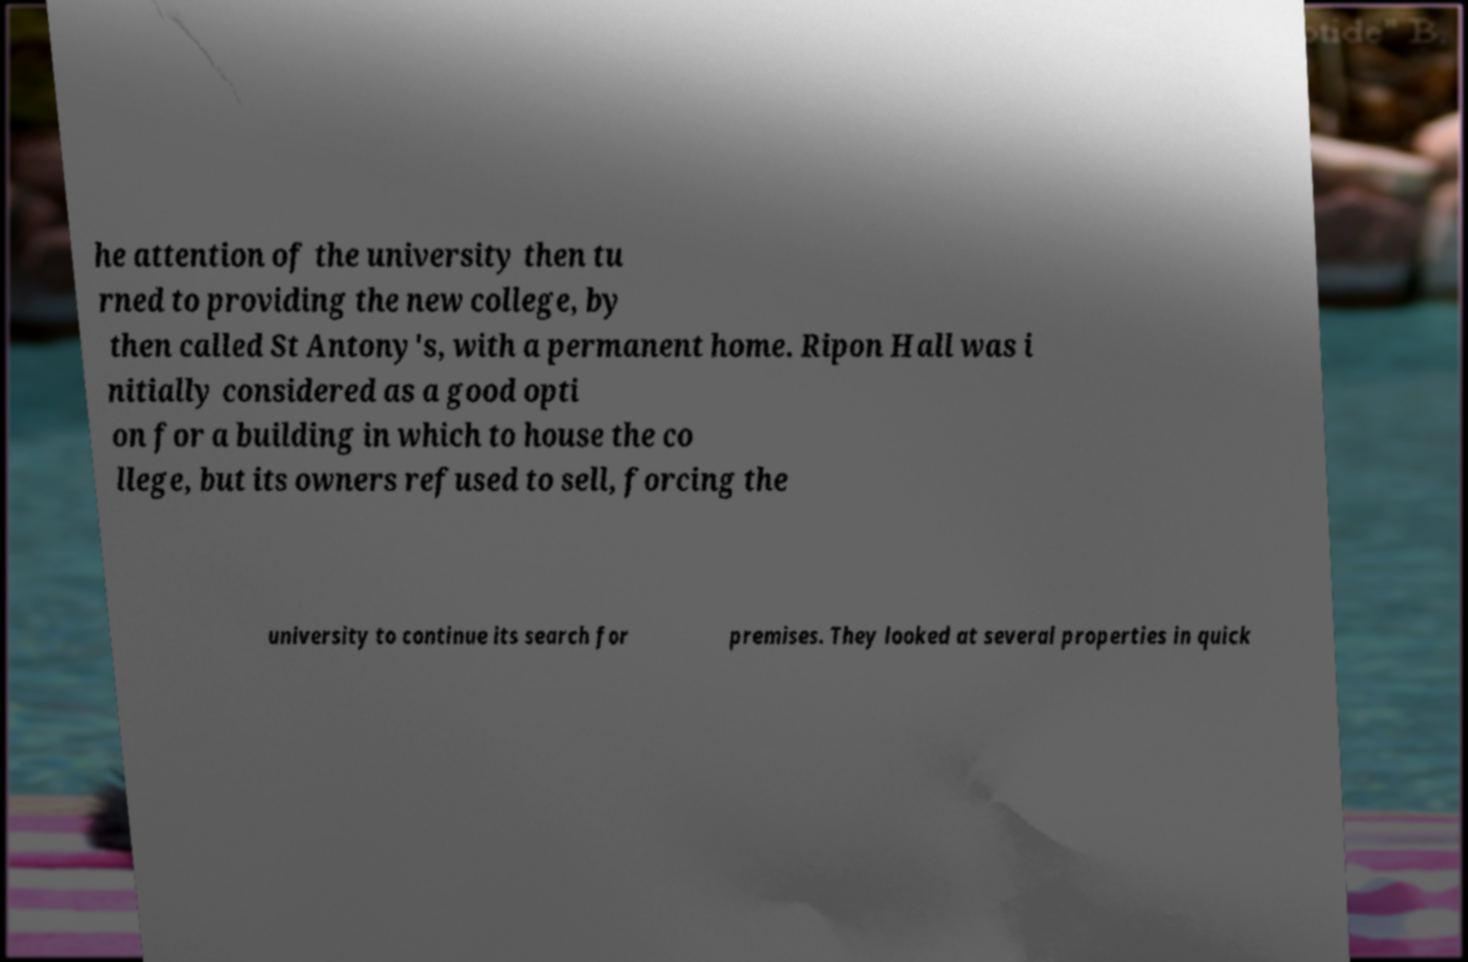Please identify and transcribe the text found in this image. he attention of the university then tu rned to providing the new college, by then called St Antony's, with a permanent home. Ripon Hall was i nitially considered as a good opti on for a building in which to house the co llege, but its owners refused to sell, forcing the university to continue its search for premises. They looked at several properties in quick 